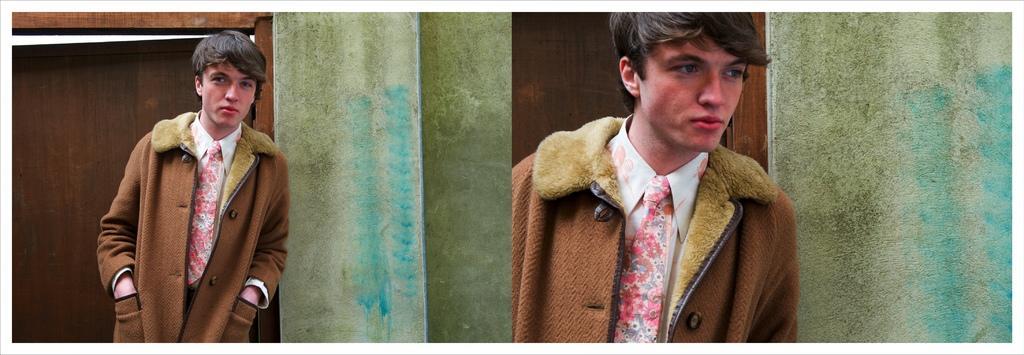How would you summarize this image in a sentence or two? On the left and right side of the image a man is present. In the background of the image we can see a wall and a door are there. 